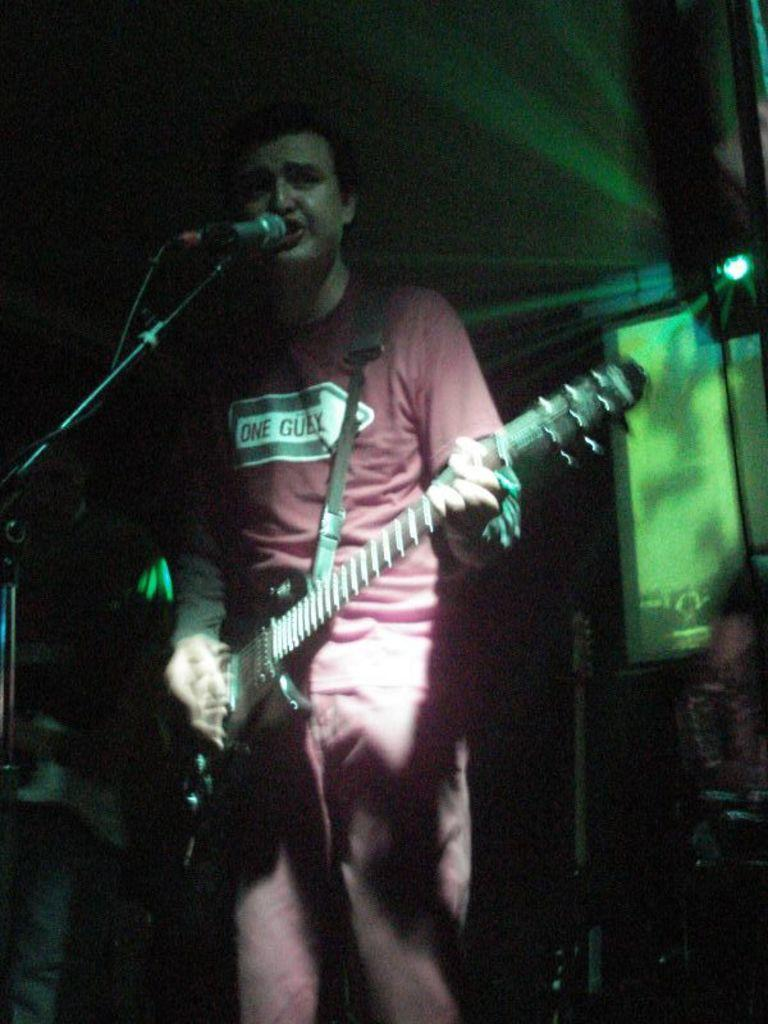What is the man in the image doing? The man is standing, playing a guitar, and singing into a microphone. What object is the man using to amplify his voice? The man is singing into a microphone. What can be seen on the right side of the image? There is a screen on the right side of the image. How would you describe the lighting in the image? The background of the image is dark. What type of popcorn is being served to the audience in the image? There is no popcorn present in the image. What is the man's desire while performing in the image? The image does not provide information about the man's desires or emotions. 